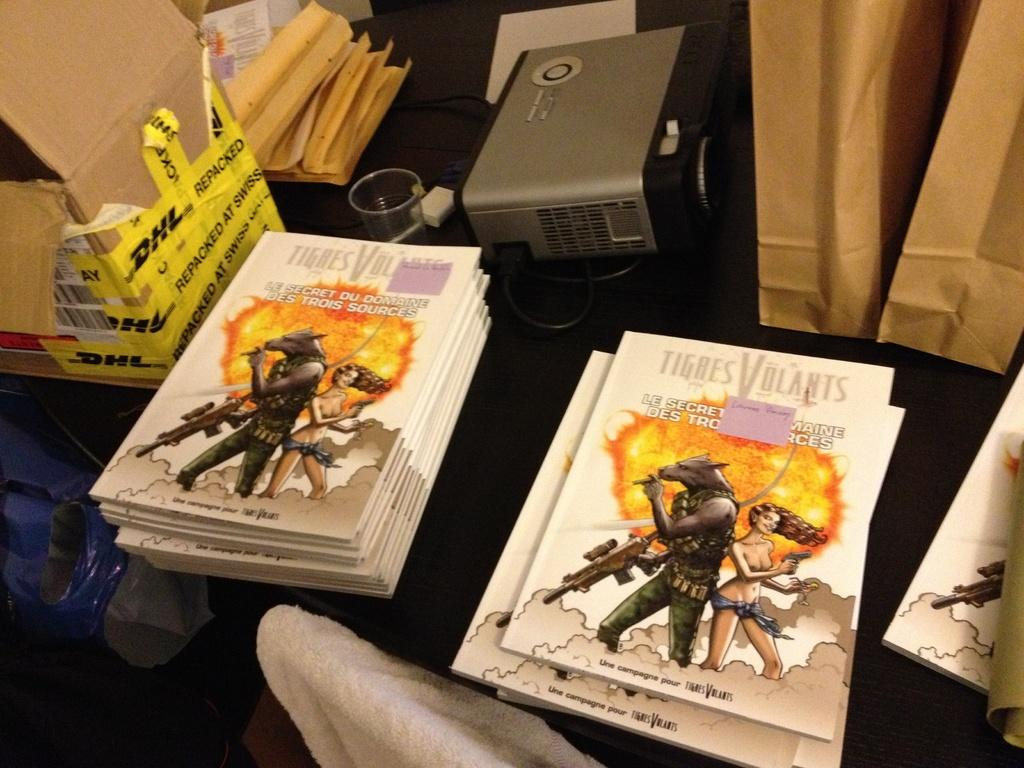<image>
Offer a succinct explanation of the picture presented. Several books by Tigres Volants are stacked on top of one another 